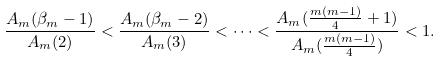<formula> <loc_0><loc_0><loc_500><loc_500>\frac { A _ { m } ( \beta _ { m } - 1 ) } { A _ { m } ( 2 ) } & < \frac { A _ { m } ( \beta _ { m } - 2 ) } { A _ { m } ( 3 ) } < \cdots < \frac { A _ { m } ( \frac { m ( m - 1 ) } { 4 } + 1 ) } { A _ { m } ( \frac { m ( m - 1 ) } { 4 } ) } < 1 .</formula> 